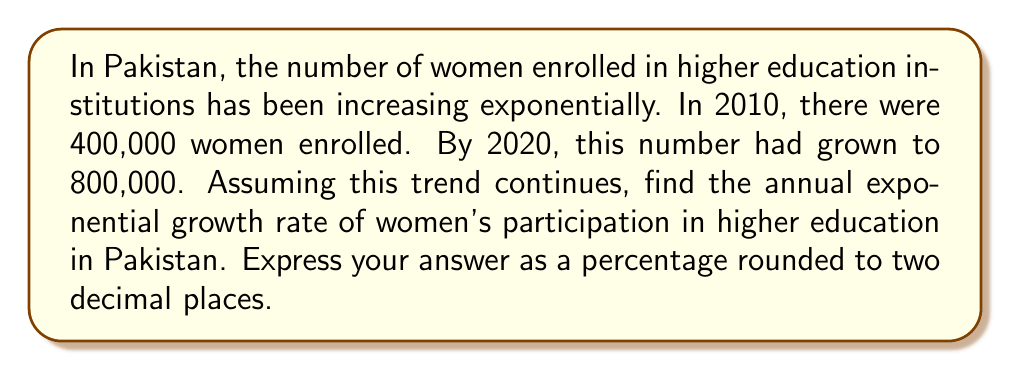Teach me how to tackle this problem. To solve this problem, we'll use the exponential growth formula:

$$A = P(1 + r)^t$$

Where:
$A$ = Final amount
$P$ = Initial amount
$r$ = Annual growth rate (in decimal form)
$t$ = Time period (in years)

Given:
$P = 400,000$ (initial enrollment in 2010)
$A = 800,000$ (final enrollment in 2020)
$t = 10$ years

Let's substitute these values into the formula:

$$800,000 = 400,000(1 + r)^{10}$$

Now, let's solve for $r$:

1) Divide both sides by 400,000:
   $$2 = (1 + r)^{10}$$

2) Take the 10th root of both sides:
   $$\sqrt[10]{2} = 1 + r$$

3) Subtract 1 from both sides:
   $$\sqrt[10]{2} - 1 = r$$

4) Calculate the value:
   $$r \approx 1.0714 - 1 = 0.0714$$

5) Convert to a percentage:
   $$0.0714 \times 100 = 7.14\%$$

Therefore, the annual exponential growth rate is approximately 7.14%.
Answer: 7.14% 